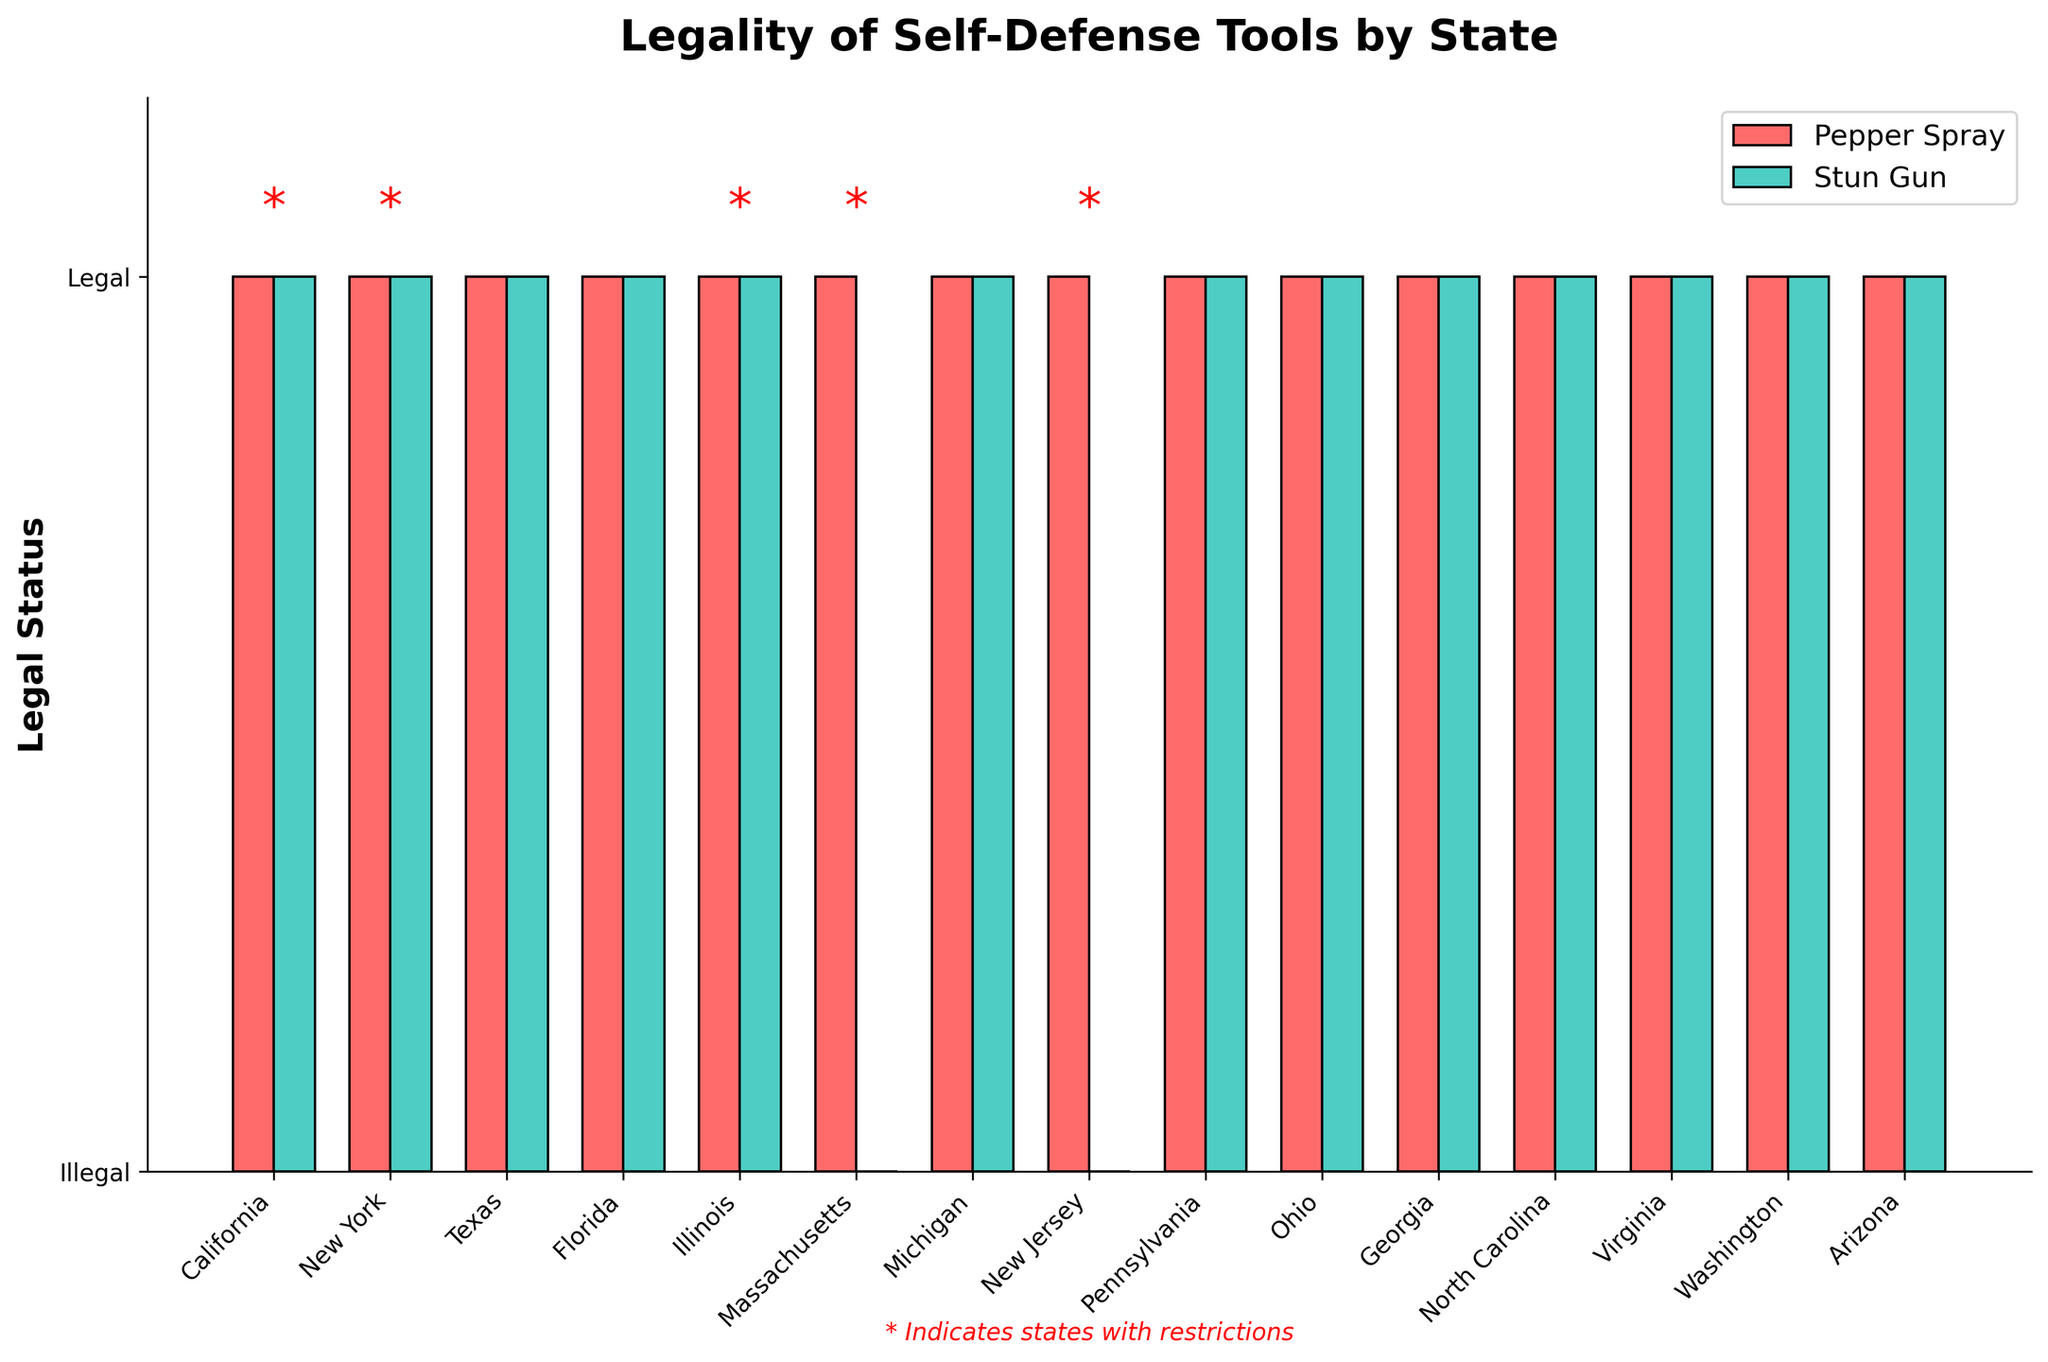which self-defense tool is more universally legal across states? Compare the number of red bars (Pepper Spray) and blue bars (Stun Gun) reaching the "Legal" level. All states have legal red bars, while two states have illegal blue bars.
Answer: Pepper Spray How many states allow both pepper spray and stun guns without restrictions? Identify states where both red and blue bars are at the "Legal" level and have no red asterisks. There are nine such states: Texas, Florida, Michigan, Pennsylvania, Ohio, Georgia, North Carolina, Virginia, and Washington.
Answer: 9 which state has the most restrictive conditions for self-defense tools? Look for states with red asterisks and check the additional information layer provided. New York and Illinois have restrictions, but New York requires a permit even for NYC.
Answer: New York how many states require a permit or card for self-defense tools? Count the number of states with red asterisks and restrictions mentioning permit or card requirements. New York, Illinois, and Massachusetts require permits or cards.
Answer: 3 in which state is pepper spray legal but stun guns illegal? Identify the state where the red bar reaches "Legal" but not the blue bar. Massachusetts fits this criterion.
Answer: Massachusetts 